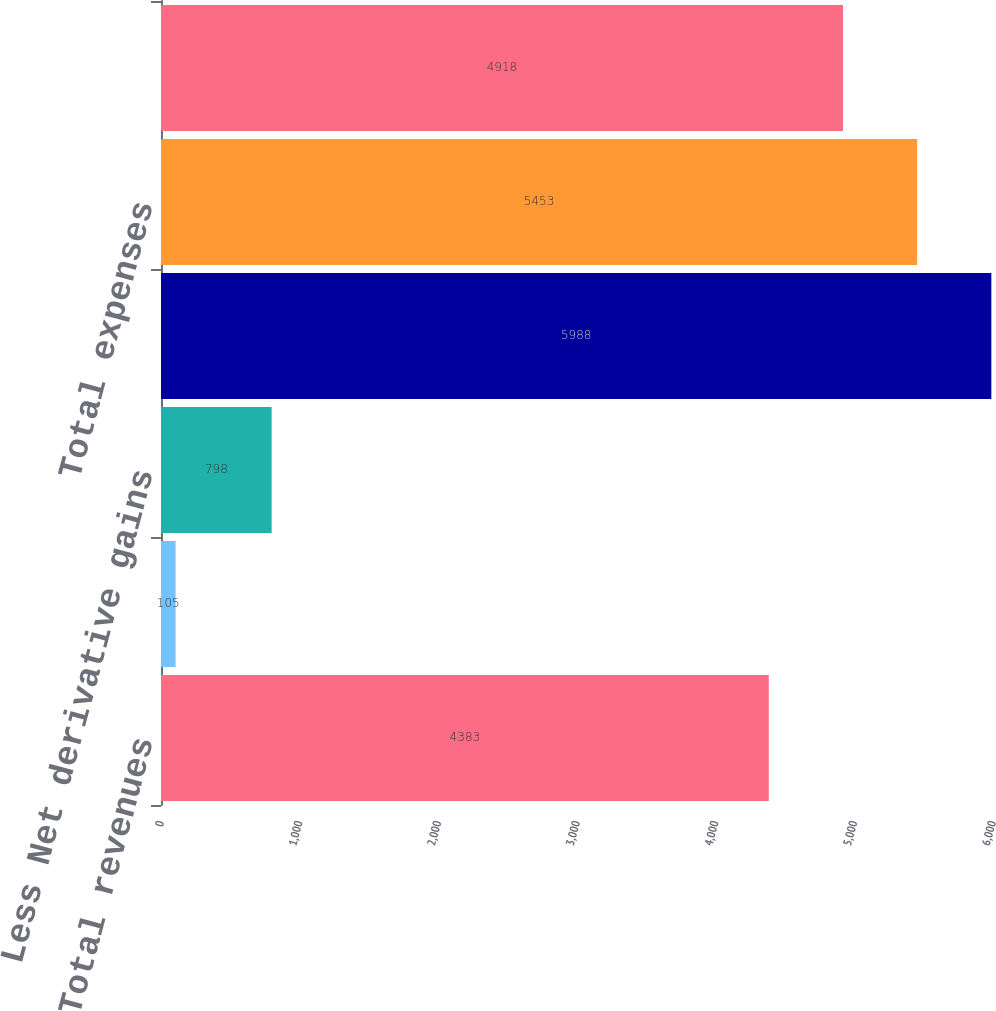<chart> <loc_0><loc_0><loc_500><loc_500><bar_chart><fcel>Total revenues<fcel>Less Net investment gains<fcel>Less Net derivative gains<fcel>Total operating revenues<fcel>Total expenses<fcel>Total operating expenses<nl><fcel>4383<fcel>105<fcel>798<fcel>5988<fcel>5453<fcel>4918<nl></chart> 